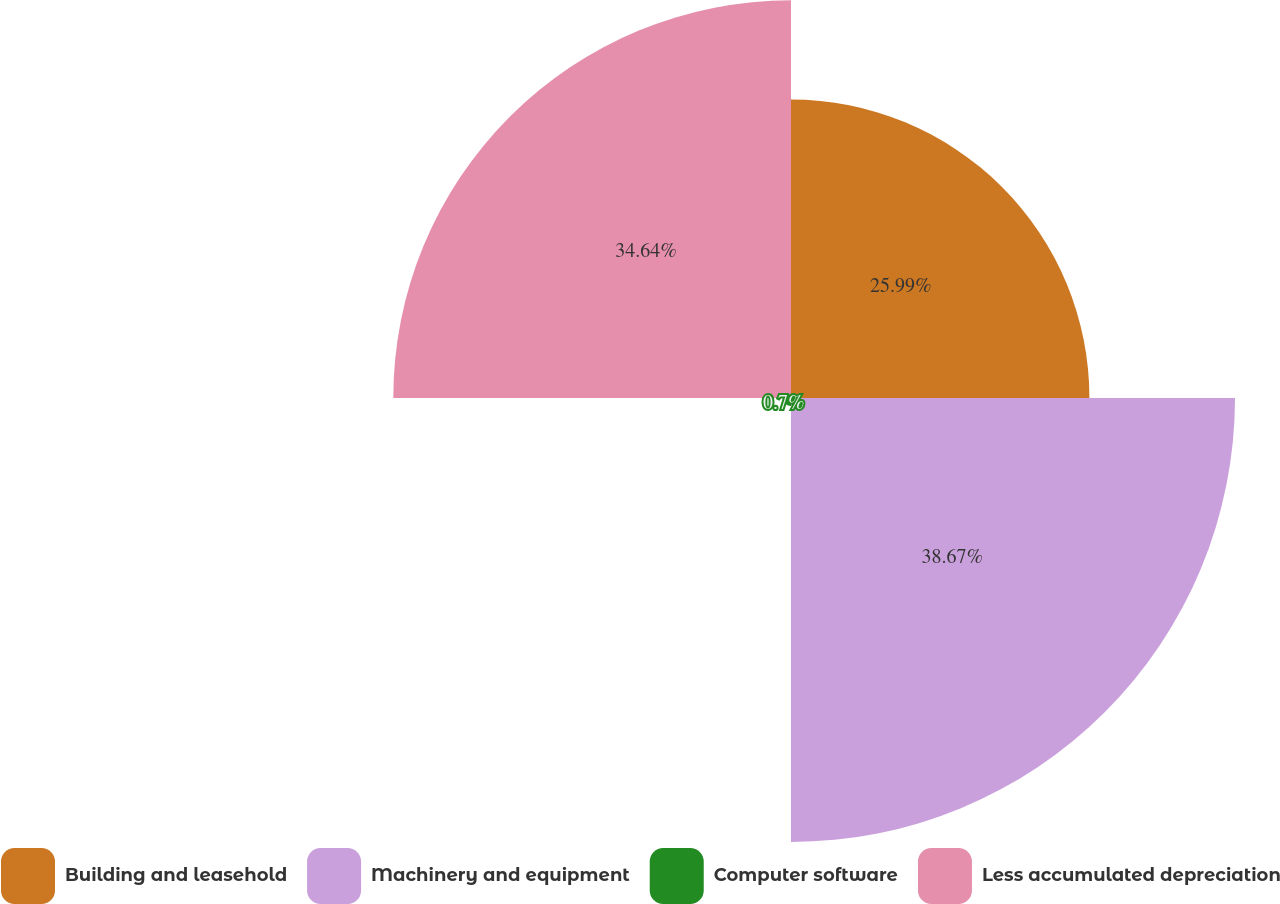<chart> <loc_0><loc_0><loc_500><loc_500><pie_chart><fcel>Building and leasehold<fcel>Machinery and equipment<fcel>Computer software<fcel>Less accumulated depreciation<nl><fcel>25.99%<fcel>38.67%<fcel>0.7%<fcel>34.64%<nl></chart> 